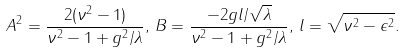<formula> <loc_0><loc_0><loc_500><loc_500>A ^ { 2 } = \frac { 2 ( \nu ^ { 2 } - 1 ) } { \nu ^ { 2 } - 1 + g ^ { 2 } / \lambda } , \, B = \frac { - 2 g l / \sqrt { \lambda } } { \nu ^ { 2 } - 1 + g ^ { 2 } / \lambda } , \, l = \sqrt { \nu ^ { 2 } - \epsilon ^ { 2 } } .</formula> 